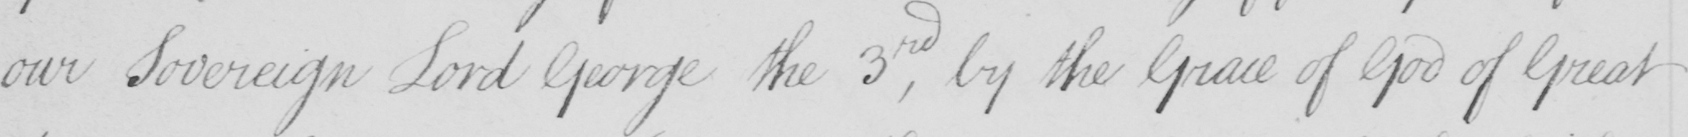What is written in this line of handwriting? our Sovereign Lord George the 3rd , by the Grace of God of Great 